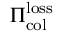<formula> <loc_0><loc_0><loc_500><loc_500>\Pi _ { c o l } ^ { l o s s }</formula> 